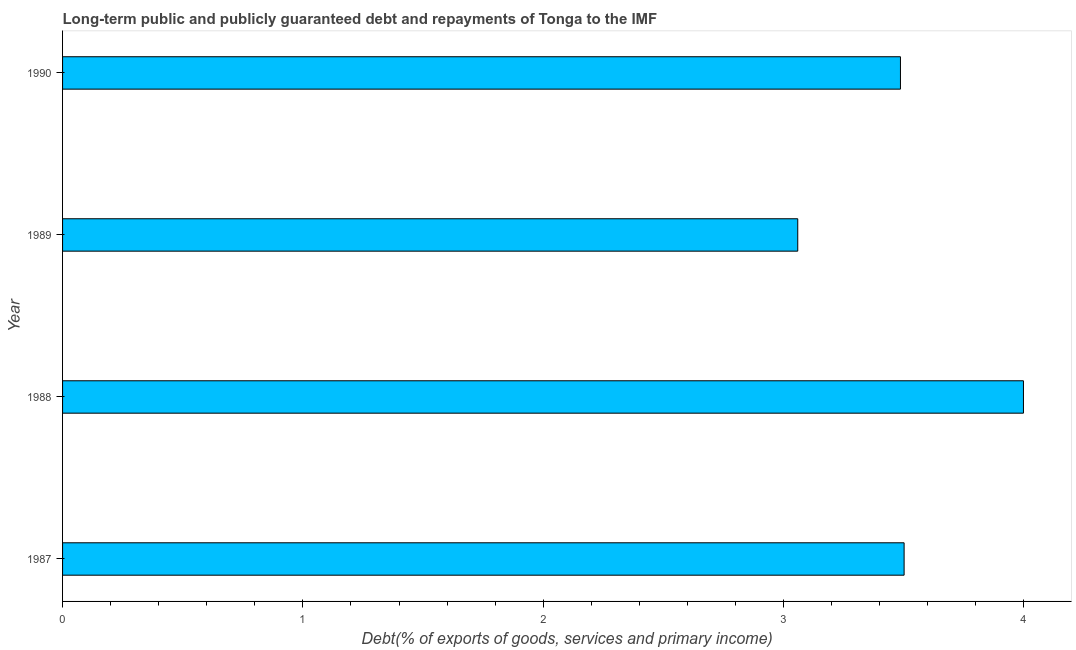What is the title of the graph?
Make the answer very short. Long-term public and publicly guaranteed debt and repayments of Tonga to the IMF. What is the label or title of the X-axis?
Your answer should be compact. Debt(% of exports of goods, services and primary income). What is the label or title of the Y-axis?
Your response must be concise. Year. What is the debt service in 1988?
Provide a succinct answer. 4. Across all years, what is the maximum debt service?
Ensure brevity in your answer.  4. Across all years, what is the minimum debt service?
Provide a short and direct response. 3.06. What is the sum of the debt service?
Offer a very short reply. 14.05. What is the difference between the debt service in 1988 and 1989?
Your answer should be very brief. 0.94. What is the average debt service per year?
Your answer should be very brief. 3.51. What is the median debt service?
Ensure brevity in your answer.  3.49. In how many years, is the debt service greater than 0.6 %?
Your answer should be compact. 4. What is the ratio of the debt service in 1987 to that in 1989?
Keep it short and to the point. 1.15. Is the debt service in 1989 less than that in 1990?
Provide a succinct answer. Yes. Is the difference between the debt service in 1988 and 1990 greater than the difference between any two years?
Your answer should be compact. No. What is the difference between the highest and the second highest debt service?
Your response must be concise. 0.5. Are all the bars in the graph horizontal?
Your answer should be compact. Yes. How many years are there in the graph?
Offer a very short reply. 4. What is the difference between two consecutive major ticks on the X-axis?
Your answer should be compact. 1. Are the values on the major ticks of X-axis written in scientific E-notation?
Ensure brevity in your answer.  No. What is the Debt(% of exports of goods, services and primary income) in 1987?
Offer a very short reply. 3.5. What is the Debt(% of exports of goods, services and primary income) of 1988?
Your response must be concise. 4. What is the Debt(% of exports of goods, services and primary income) of 1989?
Make the answer very short. 3.06. What is the Debt(% of exports of goods, services and primary income) in 1990?
Provide a succinct answer. 3.49. What is the difference between the Debt(% of exports of goods, services and primary income) in 1987 and 1988?
Keep it short and to the point. -0.5. What is the difference between the Debt(% of exports of goods, services and primary income) in 1987 and 1989?
Ensure brevity in your answer.  0.44. What is the difference between the Debt(% of exports of goods, services and primary income) in 1987 and 1990?
Ensure brevity in your answer.  0.02. What is the difference between the Debt(% of exports of goods, services and primary income) in 1988 and 1989?
Offer a terse response. 0.94. What is the difference between the Debt(% of exports of goods, services and primary income) in 1988 and 1990?
Give a very brief answer. 0.51. What is the difference between the Debt(% of exports of goods, services and primary income) in 1989 and 1990?
Your response must be concise. -0.43. What is the ratio of the Debt(% of exports of goods, services and primary income) in 1987 to that in 1988?
Make the answer very short. 0.88. What is the ratio of the Debt(% of exports of goods, services and primary income) in 1987 to that in 1989?
Your answer should be very brief. 1.15. What is the ratio of the Debt(% of exports of goods, services and primary income) in 1987 to that in 1990?
Your answer should be very brief. 1. What is the ratio of the Debt(% of exports of goods, services and primary income) in 1988 to that in 1989?
Make the answer very short. 1.31. What is the ratio of the Debt(% of exports of goods, services and primary income) in 1988 to that in 1990?
Your answer should be compact. 1.15. What is the ratio of the Debt(% of exports of goods, services and primary income) in 1989 to that in 1990?
Offer a very short reply. 0.88. 